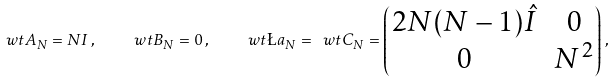<formula> <loc_0><loc_0><loc_500><loc_500>\ w t A _ { N } = N I \, , \quad \ w t B _ { N } = 0 \, , \quad \ w t \L a _ { N } = \ w t C _ { N } = \begin{pmatrix} 2 N ( N - 1 ) \hat { I } & 0 \\ 0 & N ^ { 2 } \end{pmatrix} \, ,</formula> 